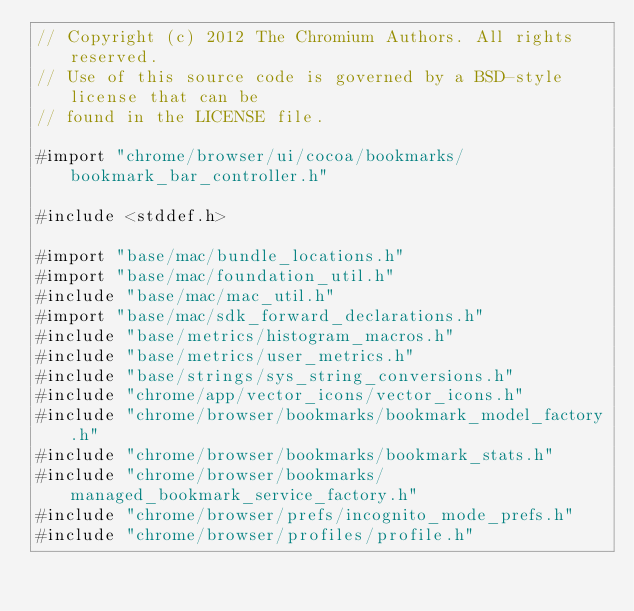Convert code to text. <code><loc_0><loc_0><loc_500><loc_500><_ObjectiveC_>// Copyright (c) 2012 The Chromium Authors. All rights reserved.
// Use of this source code is governed by a BSD-style license that can be
// found in the LICENSE file.

#import "chrome/browser/ui/cocoa/bookmarks/bookmark_bar_controller.h"

#include <stddef.h>

#import "base/mac/bundle_locations.h"
#import "base/mac/foundation_util.h"
#include "base/mac/mac_util.h"
#import "base/mac/sdk_forward_declarations.h"
#include "base/metrics/histogram_macros.h"
#include "base/metrics/user_metrics.h"
#include "base/strings/sys_string_conversions.h"
#include "chrome/app/vector_icons/vector_icons.h"
#include "chrome/browser/bookmarks/bookmark_model_factory.h"
#include "chrome/browser/bookmarks/bookmark_stats.h"
#include "chrome/browser/bookmarks/managed_bookmark_service_factory.h"
#include "chrome/browser/prefs/incognito_mode_prefs.h"
#include "chrome/browser/profiles/profile.h"</code> 